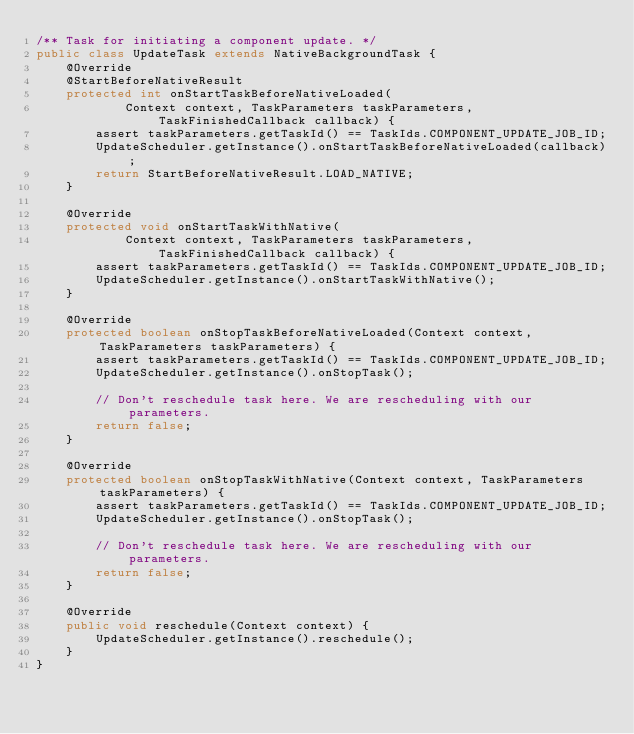Convert code to text. <code><loc_0><loc_0><loc_500><loc_500><_Java_>/** Task for initiating a component update. */
public class UpdateTask extends NativeBackgroundTask {
    @Override
    @StartBeforeNativeResult
    protected int onStartTaskBeforeNativeLoaded(
            Context context, TaskParameters taskParameters, TaskFinishedCallback callback) {
        assert taskParameters.getTaskId() == TaskIds.COMPONENT_UPDATE_JOB_ID;
        UpdateScheduler.getInstance().onStartTaskBeforeNativeLoaded(callback);
        return StartBeforeNativeResult.LOAD_NATIVE;
    }

    @Override
    protected void onStartTaskWithNative(
            Context context, TaskParameters taskParameters, TaskFinishedCallback callback) {
        assert taskParameters.getTaskId() == TaskIds.COMPONENT_UPDATE_JOB_ID;
        UpdateScheduler.getInstance().onStartTaskWithNative();
    }

    @Override
    protected boolean onStopTaskBeforeNativeLoaded(Context context, TaskParameters taskParameters) {
        assert taskParameters.getTaskId() == TaskIds.COMPONENT_UPDATE_JOB_ID;
        UpdateScheduler.getInstance().onStopTask();

        // Don't reschedule task here. We are rescheduling with our parameters.
        return false;
    }

    @Override
    protected boolean onStopTaskWithNative(Context context, TaskParameters taskParameters) {
        assert taskParameters.getTaskId() == TaskIds.COMPONENT_UPDATE_JOB_ID;
        UpdateScheduler.getInstance().onStopTask();

        // Don't reschedule task here. We are rescheduling with our parameters.
        return false;
    }

    @Override
    public void reschedule(Context context) {
        UpdateScheduler.getInstance().reschedule();
    }
}</code> 